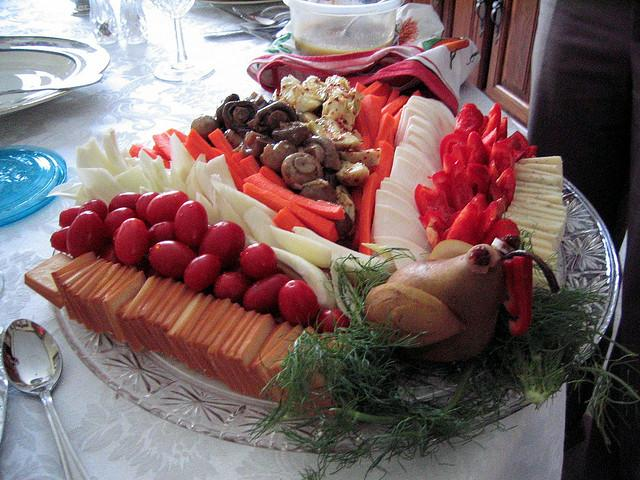What kind of food is between the mushrooms and carrots?

Choices:
A) cheese
B) fruit
C) vegetable
D) meat vegetable 